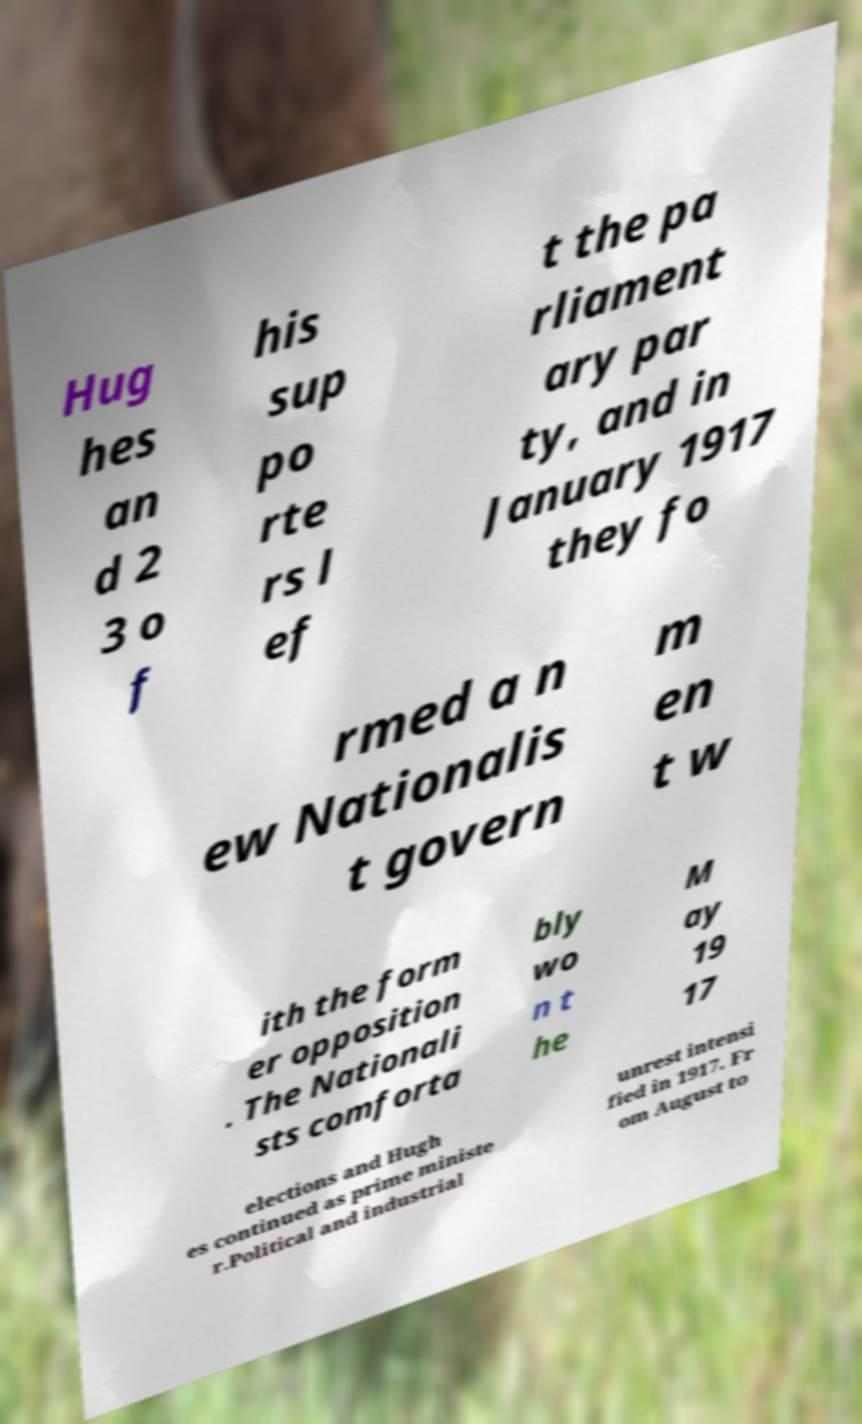There's text embedded in this image that I need extracted. Can you transcribe it verbatim? Hug hes an d 2 3 o f his sup po rte rs l ef t the pa rliament ary par ty, and in January 1917 they fo rmed a n ew Nationalis t govern m en t w ith the form er opposition . The Nationali sts comforta bly wo n t he M ay 19 17 elections and Hugh es continued as prime ministe r.Political and industrial unrest intensi fied in 1917. Fr om August to 